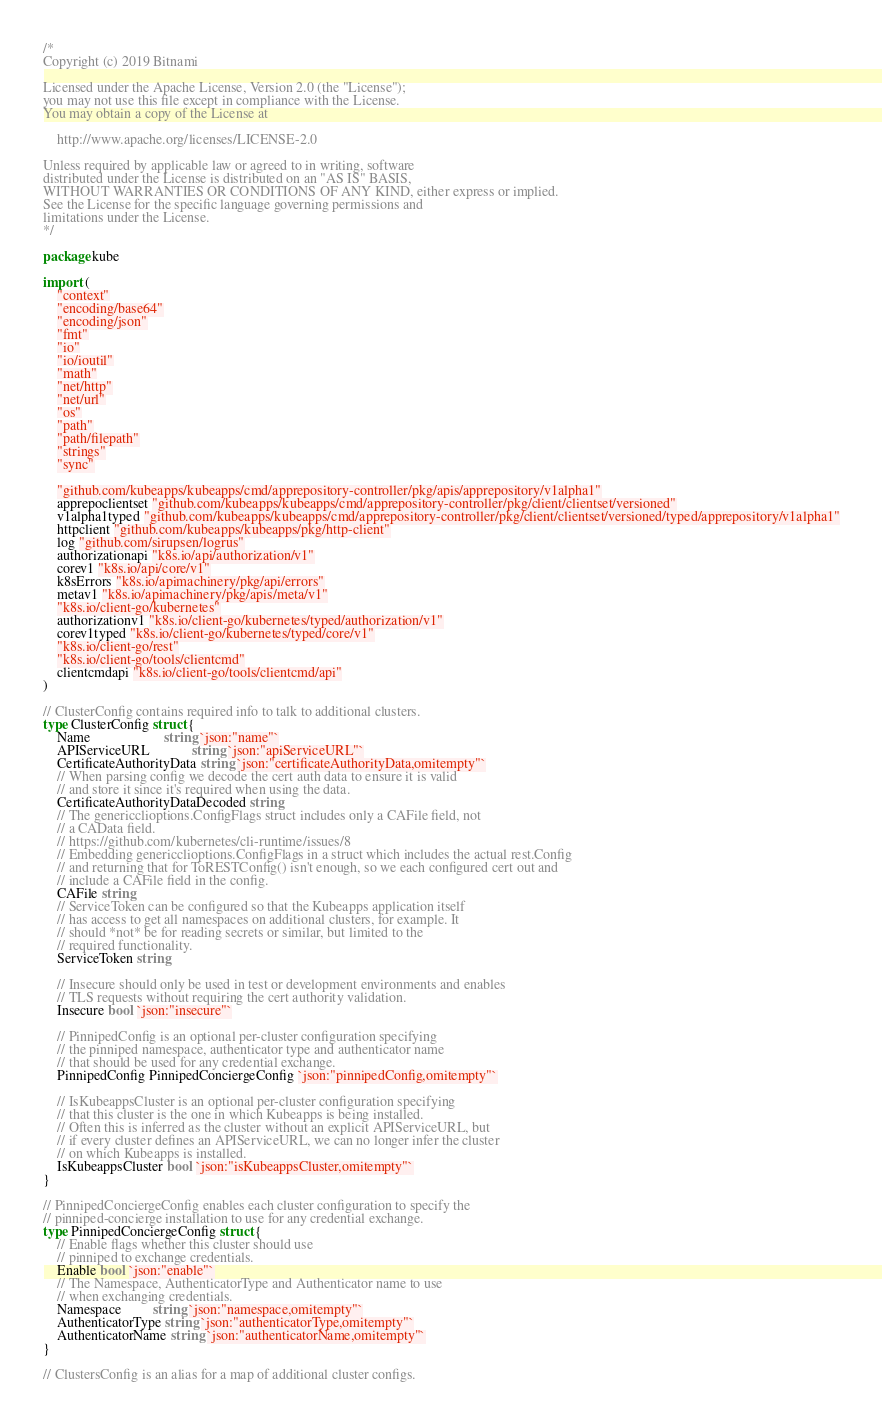<code> <loc_0><loc_0><loc_500><loc_500><_Go_>/*
Copyright (c) 2019 Bitnami

Licensed under the Apache License, Version 2.0 (the "License");
you may not use this file except in compliance with the License.
You may obtain a copy of the License at

    http://www.apache.org/licenses/LICENSE-2.0

Unless required by applicable law or agreed to in writing, software
distributed under the License is distributed on an "AS IS" BASIS,
WITHOUT WARRANTIES OR CONDITIONS OF ANY KIND, either express or implied.
See the License for the specific language governing permissions and
limitations under the License.
*/

package kube

import (
	"context"
	"encoding/base64"
	"encoding/json"
	"fmt"
	"io"
	"io/ioutil"
	"math"
	"net/http"
	"net/url"
	"os"
	"path"
	"path/filepath"
	"strings"
	"sync"

	"github.com/kubeapps/kubeapps/cmd/apprepository-controller/pkg/apis/apprepository/v1alpha1"
	apprepoclientset "github.com/kubeapps/kubeapps/cmd/apprepository-controller/pkg/client/clientset/versioned"
	v1alpha1typed "github.com/kubeapps/kubeapps/cmd/apprepository-controller/pkg/client/clientset/versioned/typed/apprepository/v1alpha1"
	httpclient "github.com/kubeapps/kubeapps/pkg/http-client"
	log "github.com/sirupsen/logrus"
	authorizationapi "k8s.io/api/authorization/v1"
	corev1 "k8s.io/api/core/v1"
	k8sErrors "k8s.io/apimachinery/pkg/api/errors"
	metav1 "k8s.io/apimachinery/pkg/apis/meta/v1"
	"k8s.io/client-go/kubernetes"
	authorizationv1 "k8s.io/client-go/kubernetes/typed/authorization/v1"
	corev1typed "k8s.io/client-go/kubernetes/typed/core/v1"
	"k8s.io/client-go/rest"
	"k8s.io/client-go/tools/clientcmd"
	clientcmdapi "k8s.io/client-go/tools/clientcmd/api"
)

// ClusterConfig contains required info to talk to additional clusters.
type ClusterConfig struct {
	Name                     string `json:"name"`
	APIServiceURL            string `json:"apiServiceURL"`
	CertificateAuthorityData string `json:"certificateAuthorityData,omitempty"`
	// When parsing config we decode the cert auth data to ensure it is valid
	// and store it since it's required when using the data.
	CertificateAuthorityDataDecoded string
	// The genericclioptions.ConfigFlags struct includes only a CAFile field, not
	// a CAData field.
	// https://github.com/kubernetes/cli-runtime/issues/8
	// Embedding genericclioptions.ConfigFlags in a struct which includes the actual rest.Config
	// and returning that for ToRESTConfig() isn't enough, so we each configured cert out and
	// include a CAFile field in the config.
	CAFile string
	// ServiceToken can be configured so that the Kubeapps application itself
	// has access to get all namespaces on additional clusters, for example. It
	// should *not* be for reading secrets or similar, but limited to the
	// required functionality.
	ServiceToken string

	// Insecure should only be used in test or development environments and enables
	// TLS requests without requiring the cert authority validation.
	Insecure bool `json:"insecure"`

	// PinnipedConfig is an optional per-cluster configuration specifying
	// the pinniped namespace, authenticator type and authenticator name
	// that should be used for any credential exchange.
	PinnipedConfig PinnipedConciergeConfig `json:"pinnipedConfig,omitempty"`

	// IsKubeappsCluster is an optional per-cluster configuration specifying
	// that this cluster is the one in which Kubeapps is being installed.
	// Often this is inferred as the cluster without an explicit APIServiceURL, but
	// if every cluster defines an APIServiceURL, we can no longer infer the cluster
	// on which Kubeapps is installed.
	IsKubeappsCluster bool `json:"isKubeappsCluster,omitempty"`
}

// PinnipedConciergeConfig enables each cluster configuration to specify the
// pinniped-concierge installation to use for any credential exchange.
type PinnipedConciergeConfig struct {
	// Enable flags whether this cluster should use
	// pinniped to exchange credentials.
	Enable bool `json:"enable"`
	// The Namespace, AuthenticatorType and Authenticator name to use
	// when exchanging credentials.
	Namespace         string `json:"namespace,omitempty"`
	AuthenticatorType string `json:"authenticatorType,omitempty"`
	AuthenticatorName string `json:"authenticatorName,omitempty"`
}

// ClustersConfig is an alias for a map of additional cluster configs.</code> 